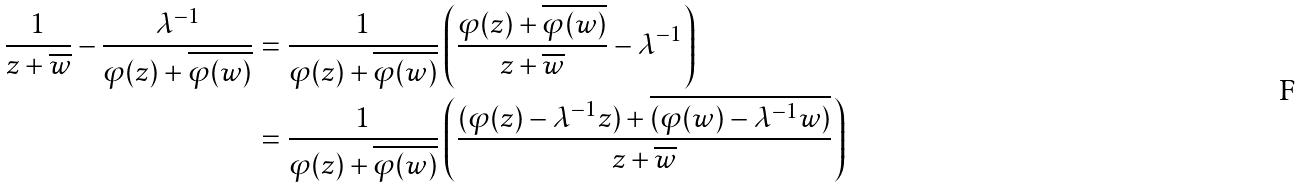Convert formula to latex. <formula><loc_0><loc_0><loc_500><loc_500>\frac { 1 } { z + \overline { w } } - \frac { \lambda ^ { - 1 } } { \varphi ( z ) + \overline { \varphi ( w ) } } & = \frac { 1 } { \varphi ( z ) + \overline { \varphi ( w ) } } \left ( \frac { \varphi ( z ) + \overline { \varphi ( w ) } } { z + \overline { w } } - \lambda ^ { - 1 } \right ) \\ & = \frac { 1 } { \varphi ( z ) + \overline { \varphi ( w ) } } \left ( \frac { ( \varphi ( z ) - \lambda ^ { - 1 } z ) + \overline { ( \varphi ( w ) - \lambda ^ { - 1 } w ) } } { z + \overline { w } } \right )</formula> 